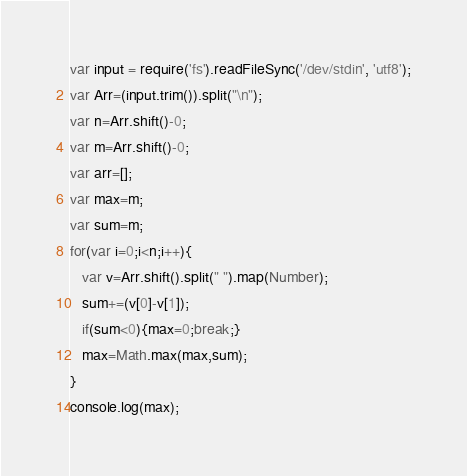<code> <loc_0><loc_0><loc_500><loc_500><_JavaScript_>var input = require('fs').readFileSync('/dev/stdin', 'utf8');
var Arr=(input.trim()).split("\n");
var n=Arr.shift()-0;
var m=Arr.shift()-0;
var arr=[];
var max=m;
var sum=m;
for(var i=0;i<n;i++){
   var v=Arr.shift().split(" ").map(Number);
   sum+=(v[0]-v[1]);
   if(sum<0){max=0;break;}
   max=Math.max(max,sum);
}
console.log(max);</code> 